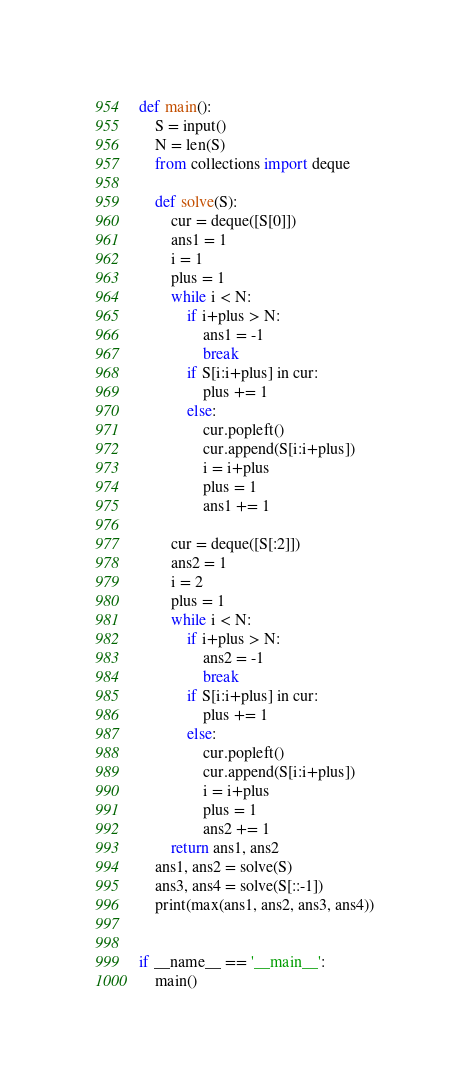Convert code to text. <code><loc_0><loc_0><loc_500><loc_500><_Python_>def main():
    S = input()
    N = len(S)
    from collections import deque

    def solve(S):
        cur = deque([S[0]])
        ans1 = 1
        i = 1
        plus = 1
        while i < N:
            if i+plus > N:
                ans1 = -1
                break
            if S[i:i+plus] in cur:
                plus += 1
            else:
                cur.popleft()
                cur.append(S[i:i+plus])
                i = i+plus
                plus = 1
                ans1 += 1

        cur = deque([S[:2]])
        ans2 = 1
        i = 2
        plus = 1
        while i < N:
            if i+plus > N:
                ans2 = -1
                break
            if S[i:i+plus] in cur:
                plus += 1
            else:
                cur.popleft()
                cur.append(S[i:i+plus])
                i = i+plus
                plus = 1
                ans2 += 1
        return ans1, ans2
    ans1, ans2 = solve(S)
    ans3, ans4 = solve(S[::-1])
    print(max(ans1, ans2, ans3, ans4))


if __name__ == '__main__':
    main()
</code> 